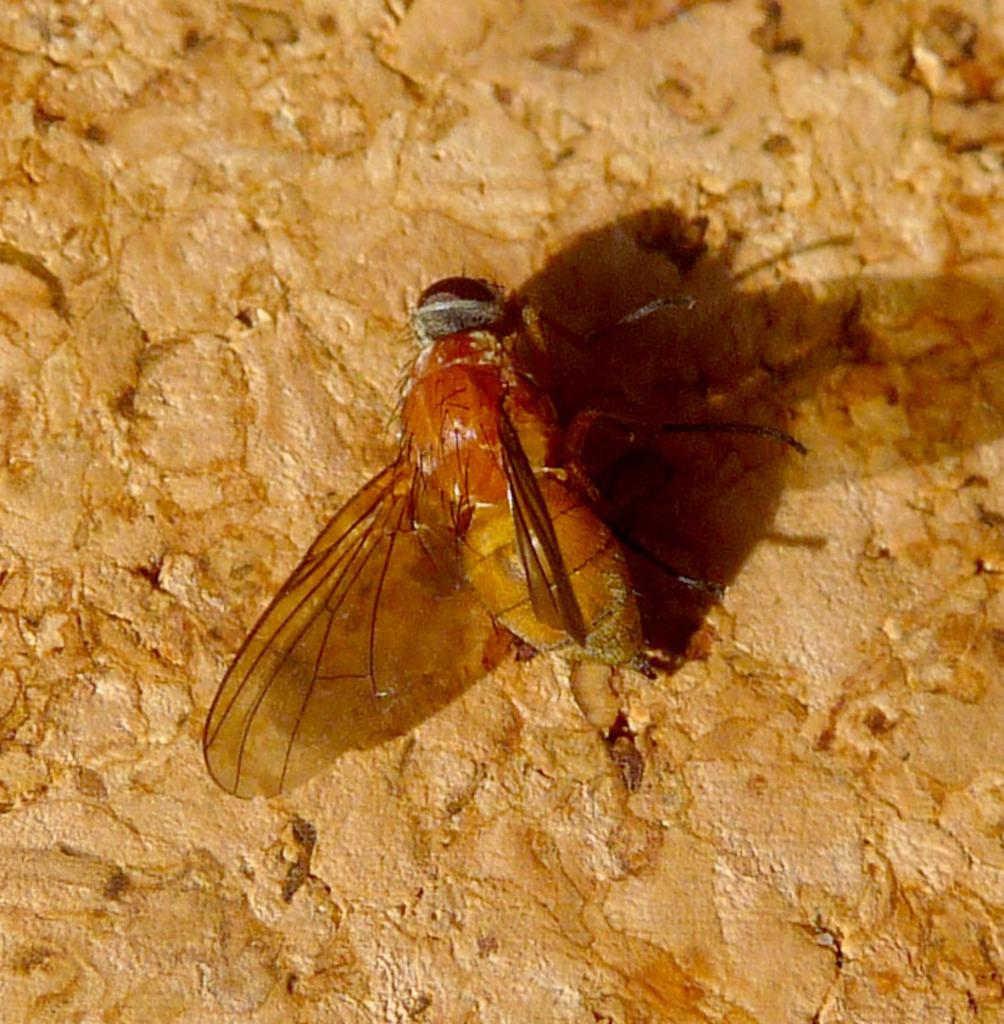What type of insect is present in the image? There is a honey bee in the image. What is the honey bee standing on in the image? The honey bee is on a brown color stone surface. What type of boat is visible in the image? There is no boat present in the image; it features a honey bee on a brown color stone surface. What type of lace is being used to create the honey bee's wings in the image? The image is a photograph of a real honey bee, and its wings are not made of lace. 